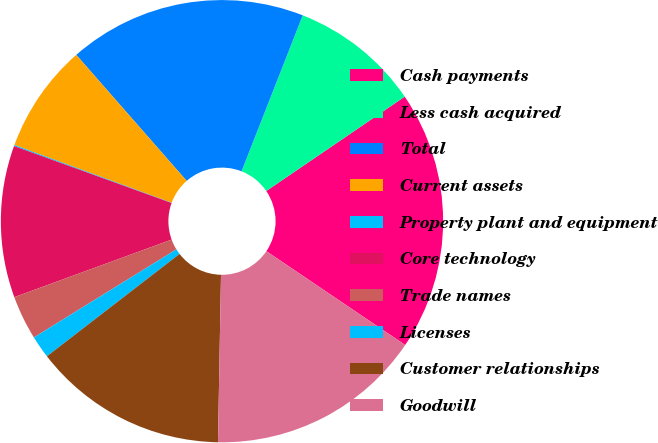Convert chart to OTSL. <chart><loc_0><loc_0><loc_500><loc_500><pie_chart><fcel>Cash payments<fcel>Less cash acquired<fcel>Total<fcel>Current assets<fcel>Property plant and equipment<fcel>Core technology<fcel>Trade names<fcel>Licenses<fcel>Customer relationships<fcel>Goodwill<nl><fcel>18.98%<fcel>9.53%<fcel>17.4%<fcel>7.95%<fcel>0.08%<fcel>11.1%<fcel>3.23%<fcel>1.65%<fcel>14.25%<fcel>15.83%<nl></chart> 